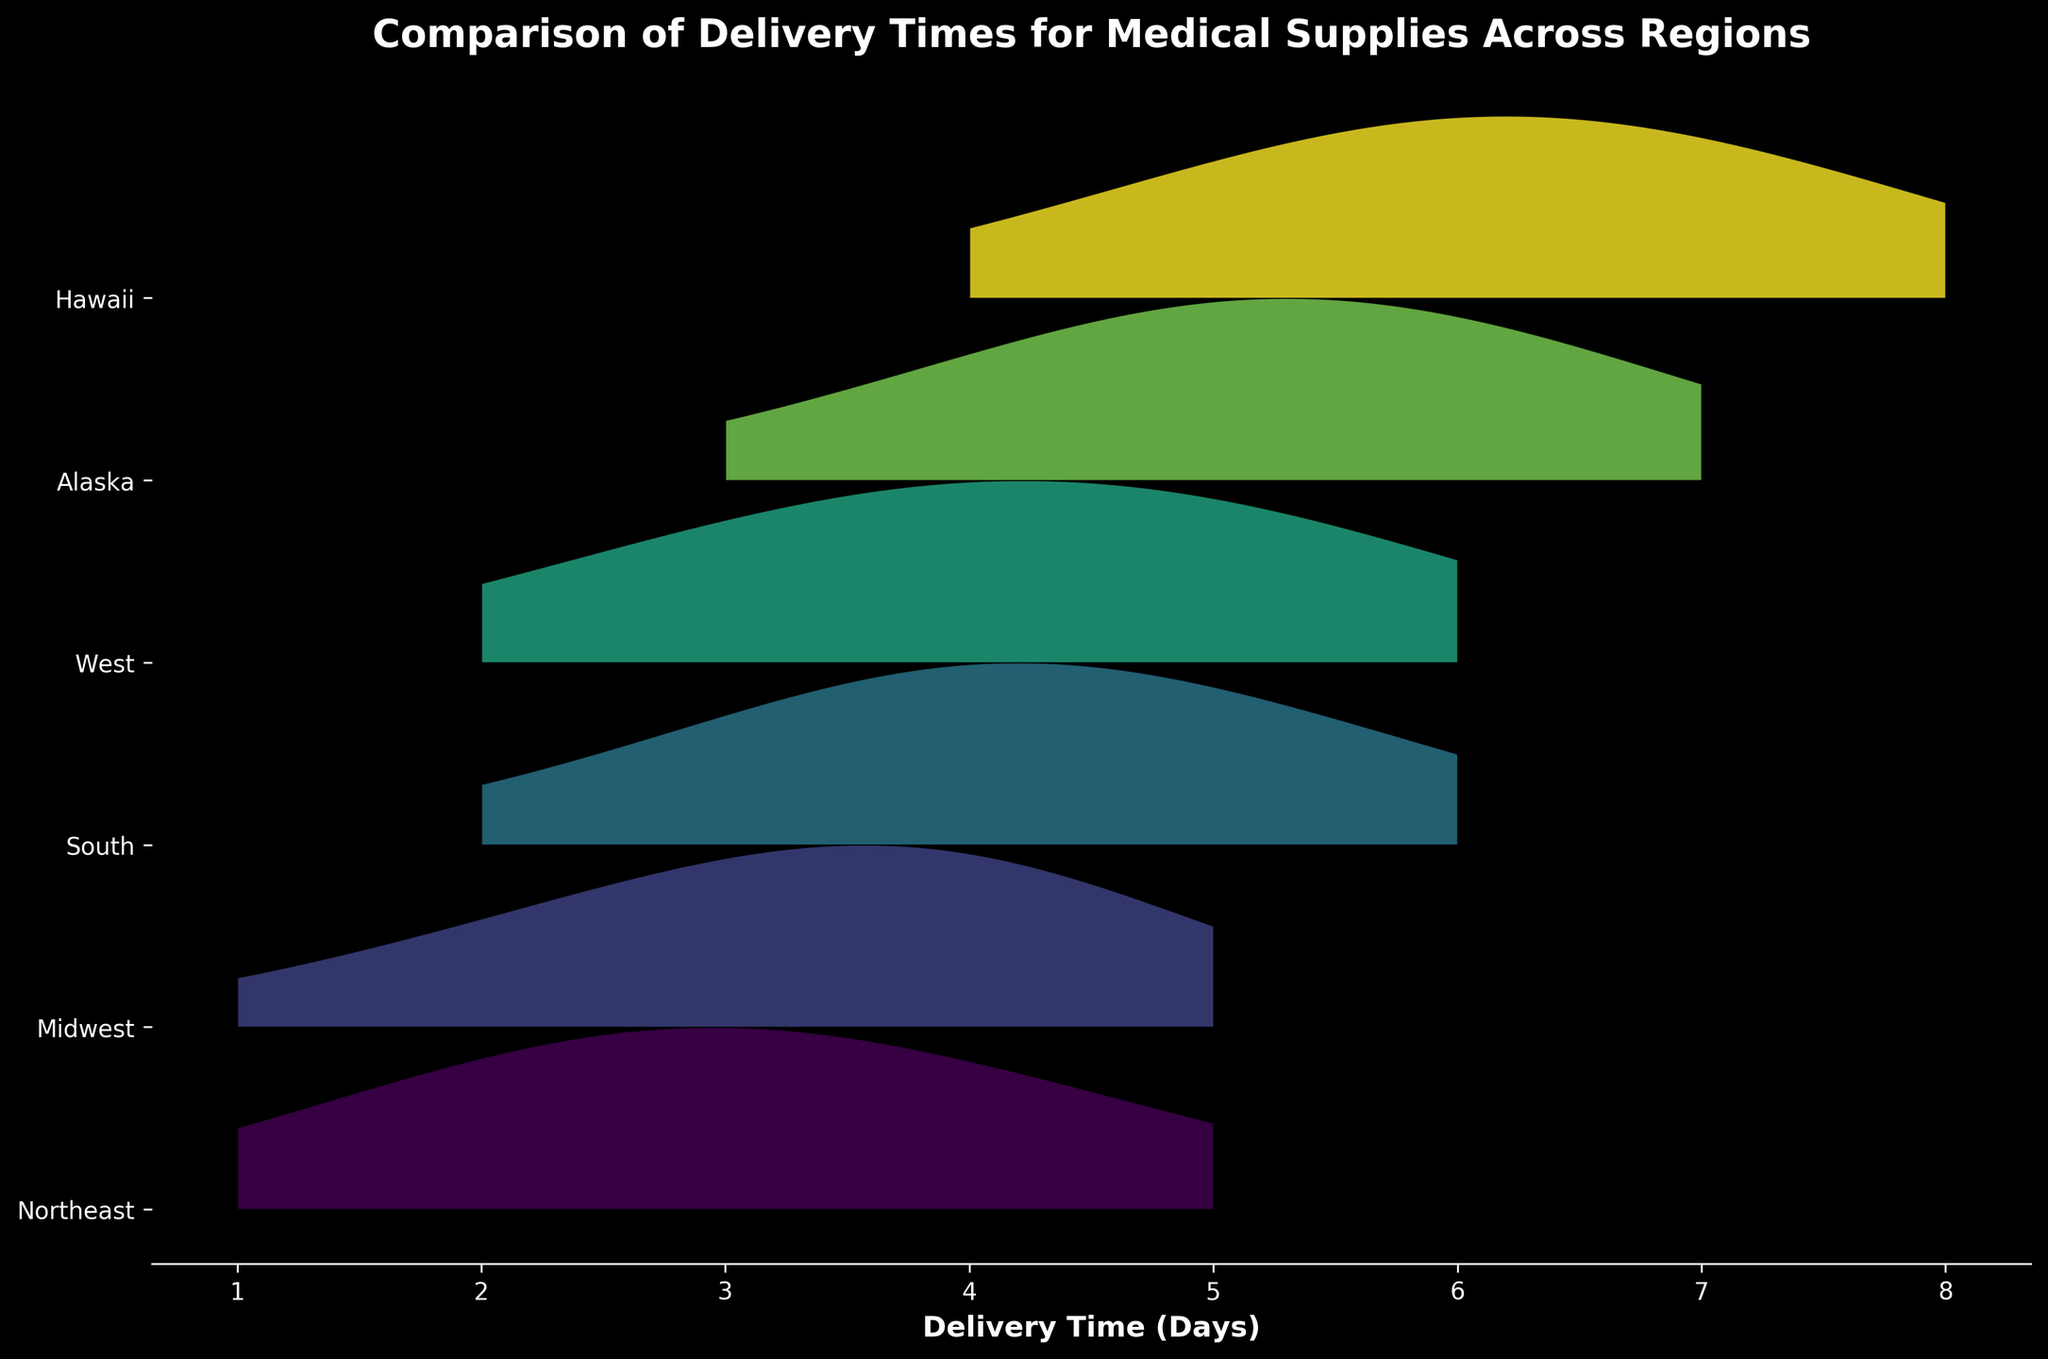What's the title of the figure? The title is typically displayed at the top of the figure. Here, it reads 'Comparison of Delivery Times for Medical Supplies Across Regions'.
Answer: Comparison of Delivery Times for Medical Supplies Across Regions What does the x-axis represent? The x-axis label indicates what is measured along this axis. Here, it is labeled 'Delivery Time (Days)'.
Answer: Delivery Time (Days) How many regions are compared in the figure? Counting the number of unique labels on the y-axis will give the number of regions. Here, the y-axis has six labels: Northeast, Midwest, South, West, Alaska, Hawaii.
Answer: Six regions Which region shows the longest delivery times? To identify the region with the longest delivery times, observe the rightmost peaks in the ridgeline plot. Alaska and Hawaii have delivery times extending up to 7 and 8 days. Hawaii has the longest, extending to 8 days.
Answer: Hawaii Which region has the shortest delivery times? To find the region with the shortest delivery times, look for the leftmost peak and the x-axis tick marks. The Northeast region has delivery times starting at 1 day.
Answer: Northeast In which region do delivery times range most widely? To determine the region with the widest range, consider the span of values on the x-axis for each region. Hawaii's delivery times range from 4 to 8 days, which seems to be the widest span.
Answer: Hawaii Compare the most frequent delivery times between the Northeast and Midwest regions. Identify the peaks of the density curves for these regions. The Northeast peaks at 3 days, while the Midwest peaks at 4 days.
Answer: Northeast (3 days) and Midwest (4 days) Which region exhibits a multimodal pattern in delivery times? A multimodal distribution will have multiple peaks within its curve. Both the South and West regions display multiple peaks, indicating variability in delivery times.
Answer: South and West Is the peak delivery time for Alaska earlier than that for the South? Compare the location of the peaks. Alaska peaks around 5 days, while the South peaks around 4 days. Therefore, the peak delivery time for Alaska is not earlier than that for the South.
Answer: No Which region has a higher density for delivery times of 6 days: Alaska or Hawaii? Look at the height of the curves at 6 days for each region. Hawaii has a higher density at 6 days compared to Alaska.
Answer: Hawaii 